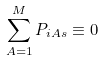<formula> <loc_0><loc_0><loc_500><loc_500>\sum _ { A = 1 } ^ { M } P _ { i A s } \equiv 0</formula> 